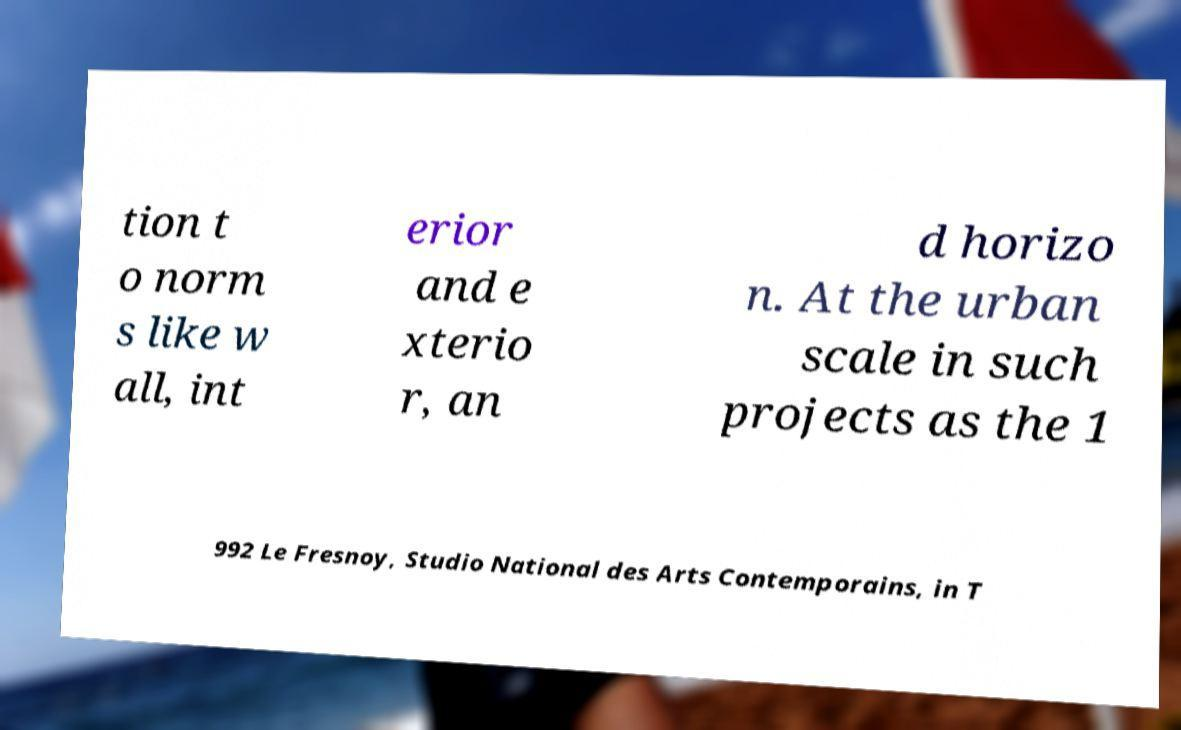Please read and relay the text visible in this image. What does it say? tion t o norm s like w all, int erior and e xterio r, an d horizo n. At the urban scale in such projects as the 1 992 Le Fresnoy, Studio National des Arts Contemporains, in T 